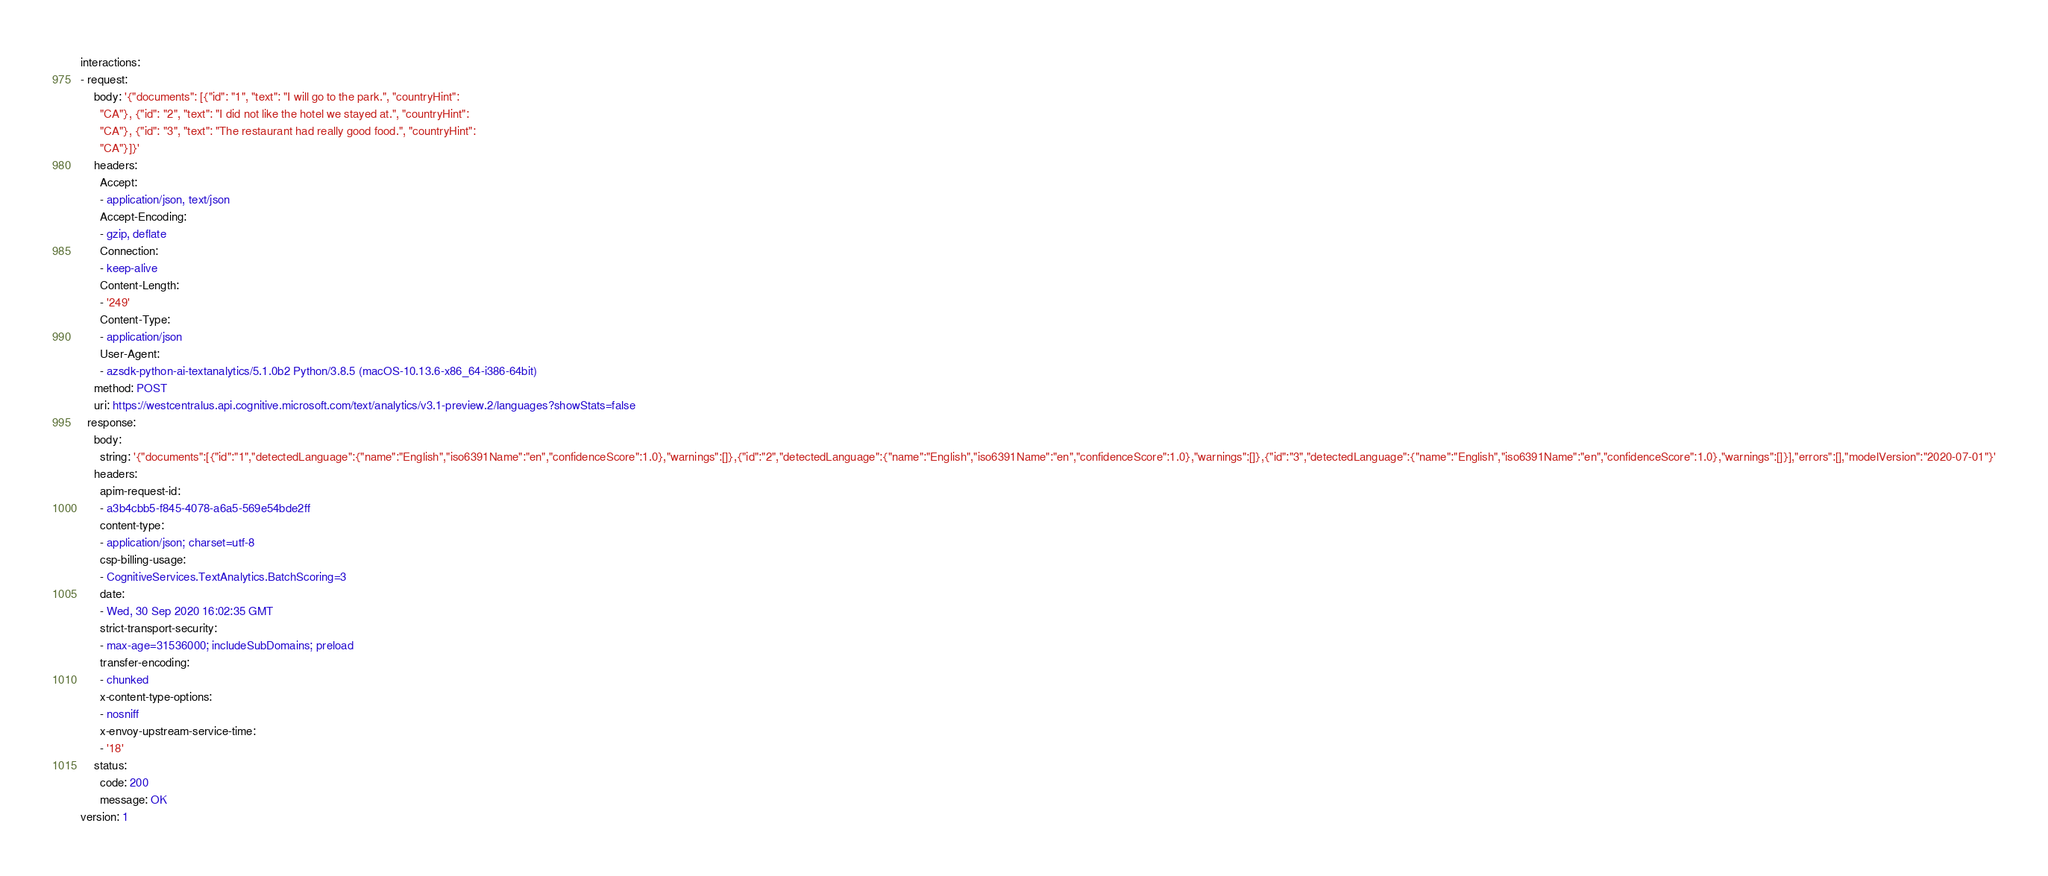<code> <loc_0><loc_0><loc_500><loc_500><_YAML_>interactions:
- request:
    body: '{"documents": [{"id": "1", "text": "I will go to the park.", "countryHint":
      "CA"}, {"id": "2", "text": "I did not like the hotel we stayed at.", "countryHint":
      "CA"}, {"id": "3", "text": "The restaurant had really good food.", "countryHint":
      "CA"}]}'
    headers:
      Accept:
      - application/json, text/json
      Accept-Encoding:
      - gzip, deflate
      Connection:
      - keep-alive
      Content-Length:
      - '249'
      Content-Type:
      - application/json
      User-Agent:
      - azsdk-python-ai-textanalytics/5.1.0b2 Python/3.8.5 (macOS-10.13.6-x86_64-i386-64bit)
    method: POST
    uri: https://westcentralus.api.cognitive.microsoft.com/text/analytics/v3.1-preview.2/languages?showStats=false
  response:
    body:
      string: '{"documents":[{"id":"1","detectedLanguage":{"name":"English","iso6391Name":"en","confidenceScore":1.0},"warnings":[]},{"id":"2","detectedLanguage":{"name":"English","iso6391Name":"en","confidenceScore":1.0},"warnings":[]},{"id":"3","detectedLanguage":{"name":"English","iso6391Name":"en","confidenceScore":1.0},"warnings":[]}],"errors":[],"modelVersion":"2020-07-01"}'
    headers:
      apim-request-id:
      - a3b4cbb5-f845-4078-a6a5-569e54bde2ff
      content-type:
      - application/json; charset=utf-8
      csp-billing-usage:
      - CognitiveServices.TextAnalytics.BatchScoring=3
      date:
      - Wed, 30 Sep 2020 16:02:35 GMT
      strict-transport-security:
      - max-age=31536000; includeSubDomains; preload
      transfer-encoding:
      - chunked
      x-content-type-options:
      - nosniff
      x-envoy-upstream-service-time:
      - '18'
    status:
      code: 200
      message: OK
version: 1
</code> 